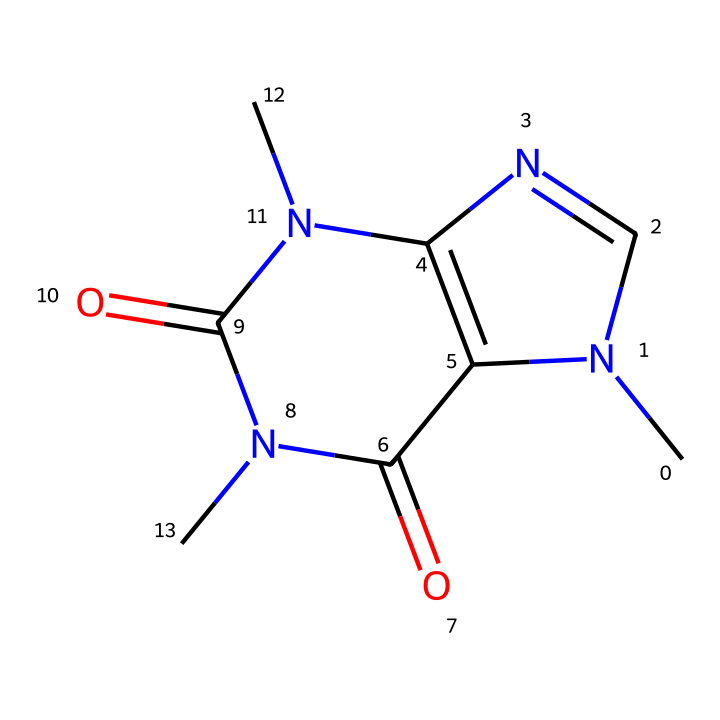what is the molecular formula of this chemical? The SMILES representation indicates there are two nitrogen (N), four carbon (C), and four oxygen (O) atoms. This can be counted from the structure as there are two N indicated and the total number of C and O atoms can be counted as well.
Answer: C4H4N4O2 how many rings are present in the structure? The number of closed loops or cycles in a chemical structure represents rings. By analyzing the SMILES, we can spot two ring structures in this molecule, as identified by the '1' and '2' markers.
Answer: 2 does this chemical contain any functional groups? Functional groups are specific groups of atoms that provide characteristic chemical reactions. In this SMILES, the presence of ‘=O’ indicates carbonyl groups (C=O), which is common in amides and means there are functional groups present.
Answer: yes what type of chemical interaction might this chemical primarily undergo? Given its nitrogen and oxygen presence, along with its molecular structure, this chemical can exhibit hydrogen bonding due to the polar nature of the N-H and O atoms as well as possible interactions due to its hydrogen bonding capabilities.
Answer: hydrogen bonding what is the primary biological effect of this chemical? This chemical is known to be a stimulant, which means it affects the central nervous system, often leading to increased alertness and decreased fatigue. This effect is common among many compounds falling into the class of stimulants, which caffeine belongs to.
Answer: stimulant can this chemical be considered toxic? Toxicity often relates to the quantity consumed. While caffeine is generally safe in moderate doses, excessive consumption can lead to toxic effects such as jitteriness, increased heart rate, and anxiety. Therefore, yes, it can be toxic in high doses.
Answer: yes 